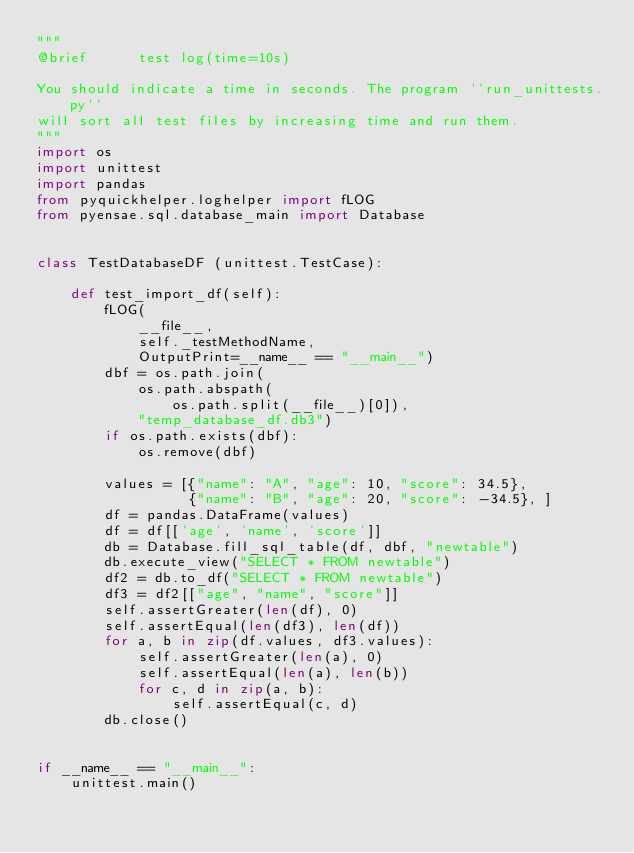Convert code to text. <code><loc_0><loc_0><loc_500><loc_500><_Python_>"""
@brief      test log(time=10s)

You should indicate a time in seconds. The program ``run_unittests.py``
will sort all test files by increasing time and run them.
"""
import os
import unittest
import pandas
from pyquickhelper.loghelper import fLOG
from pyensae.sql.database_main import Database


class TestDatabaseDF (unittest.TestCase):

    def test_import_df(self):
        fLOG(
            __file__,
            self._testMethodName,
            OutputPrint=__name__ == "__main__")
        dbf = os.path.join(
            os.path.abspath(
                os.path.split(__file__)[0]),
            "temp_database_df.db3")
        if os.path.exists(dbf):
            os.remove(dbf)

        values = [{"name": "A", "age": 10, "score": 34.5},
                  {"name": "B", "age": 20, "score": -34.5}, ]
        df = pandas.DataFrame(values)
        df = df[['age', 'name', 'score']]
        db = Database.fill_sql_table(df, dbf, "newtable")
        db.execute_view("SELECT * FROM newtable")
        df2 = db.to_df("SELECT * FROM newtable")
        df3 = df2[["age", "name", "score"]]
        self.assertGreater(len(df), 0)
        self.assertEqual(len(df3), len(df))
        for a, b in zip(df.values, df3.values):
            self.assertGreater(len(a), 0)
            self.assertEqual(len(a), len(b))
            for c, d in zip(a, b):
                self.assertEqual(c, d)
        db.close()


if __name__ == "__main__":
    unittest.main()
</code> 